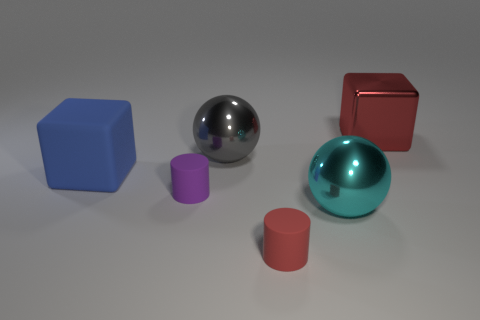Add 1 tiny metal things. How many objects exist? 7 Subtract 2 blocks. How many blocks are left? 0 Add 1 large metal balls. How many large metal balls exist? 3 Subtract 1 gray balls. How many objects are left? 5 Subtract all blocks. How many objects are left? 4 Subtract all cyan cylinders. Subtract all brown blocks. How many cylinders are left? 2 Subtract all blue cylinders. How many gray cubes are left? 0 Subtract all large blue things. Subtract all large blue cubes. How many objects are left? 4 Add 2 cyan balls. How many cyan balls are left? 3 